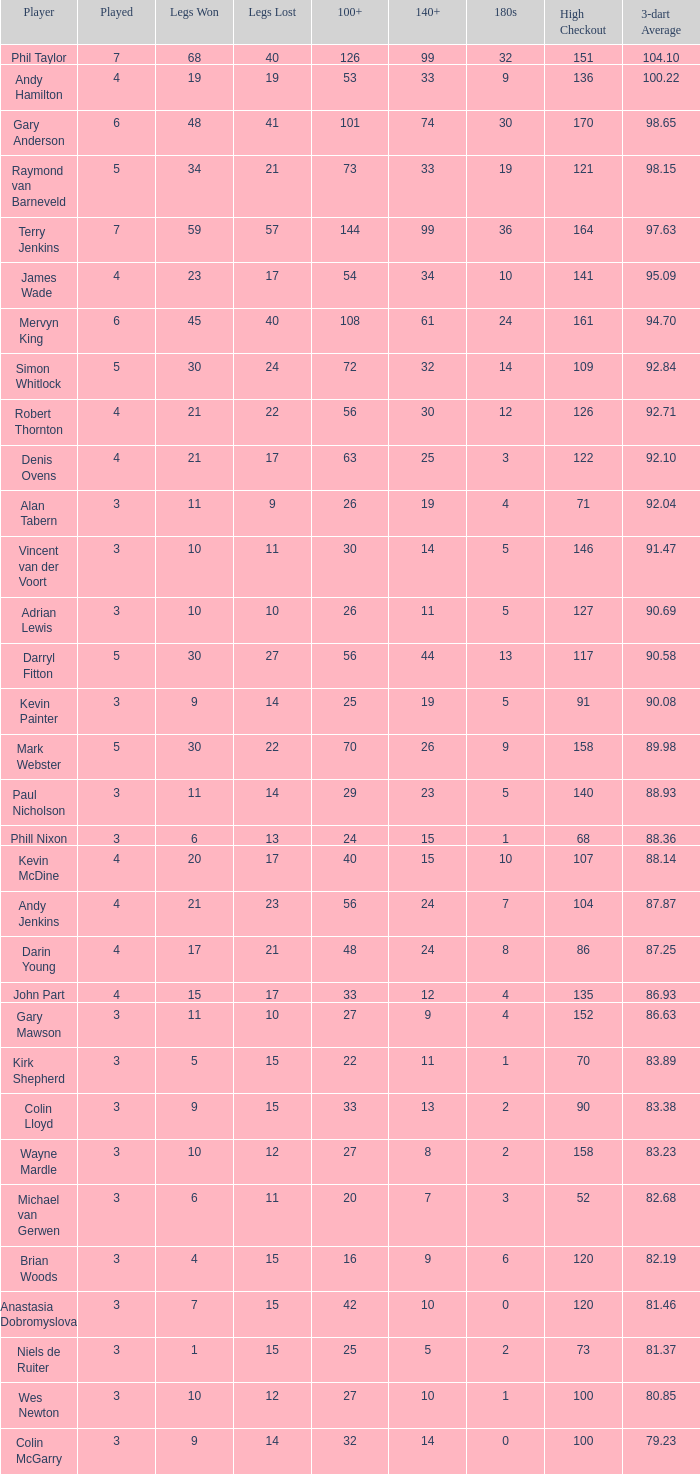What is the peak checkout when legs won is fewer than 9, a 180s of 1, and a 3-dart average surpassing 8 None. 